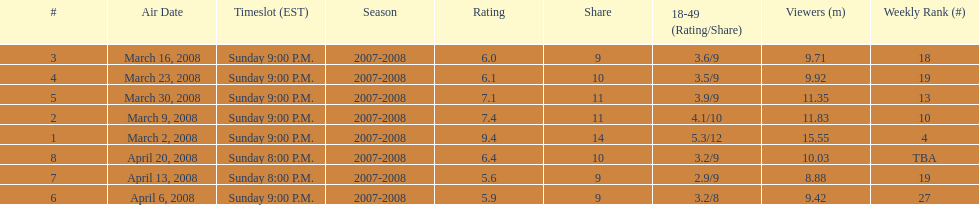How long did the program air for in days? 8. Parse the full table. {'header': ['#', 'Air Date', 'Timeslot (EST)', 'Season', 'Rating', 'Share', '18-49 (Rating/Share)', 'Viewers (m)', 'Weekly Rank (#)'], 'rows': [['3', 'March 16, 2008', 'Sunday 9:00 P.M.', '2007-2008', '6.0', '9', '3.6/9', '9.71', '18'], ['4', 'March 23, 2008', 'Sunday 9:00 P.M.', '2007-2008', '6.1', '10', '3.5/9', '9.92', '19'], ['5', 'March 30, 2008', 'Sunday 9:00 P.M.', '2007-2008', '7.1', '11', '3.9/9', '11.35', '13'], ['2', 'March 9, 2008', 'Sunday 9:00 P.M.', '2007-2008', '7.4', '11', '4.1/10', '11.83', '10'], ['1', 'March 2, 2008', 'Sunday 9:00 P.M.', '2007-2008', '9.4', '14', '5.3/12', '15.55', '4'], ['8', 'April 20, 2008', 'Sunday 8:00 P.M.', '2007-2008', '6.4', '10', '3.2/9', '10.03', 'TBA'], ['7', 'April 13, 2008', 'Sunday 8:00 P.M.', '2007-2008', '5.6', '9', '2.9/9', '8.88', '19'], ['6', 'April 6, 2008', 'Sunday 9:00 P.M.', '2007-2008', '5.9', '9', '3.2/8', '9.42', '27']]} 